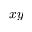Convert formula to latex. <formula><loc_0><loc_0><loc_500><loc_500>x y</formula> 